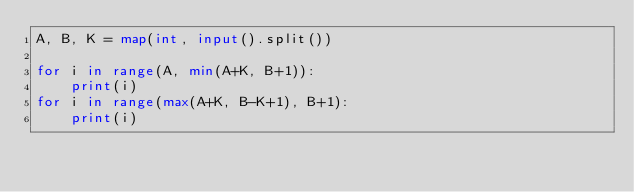<code> <loc_0><loc_0><loc_500><loc_500><_Python_>A, B, K = map(int, input().split())

for i in range(A, min(A+K, B+1)):
    print(i)
for i in range(max(A+K, B-K+1), B+1):
    print(i)
</code> 